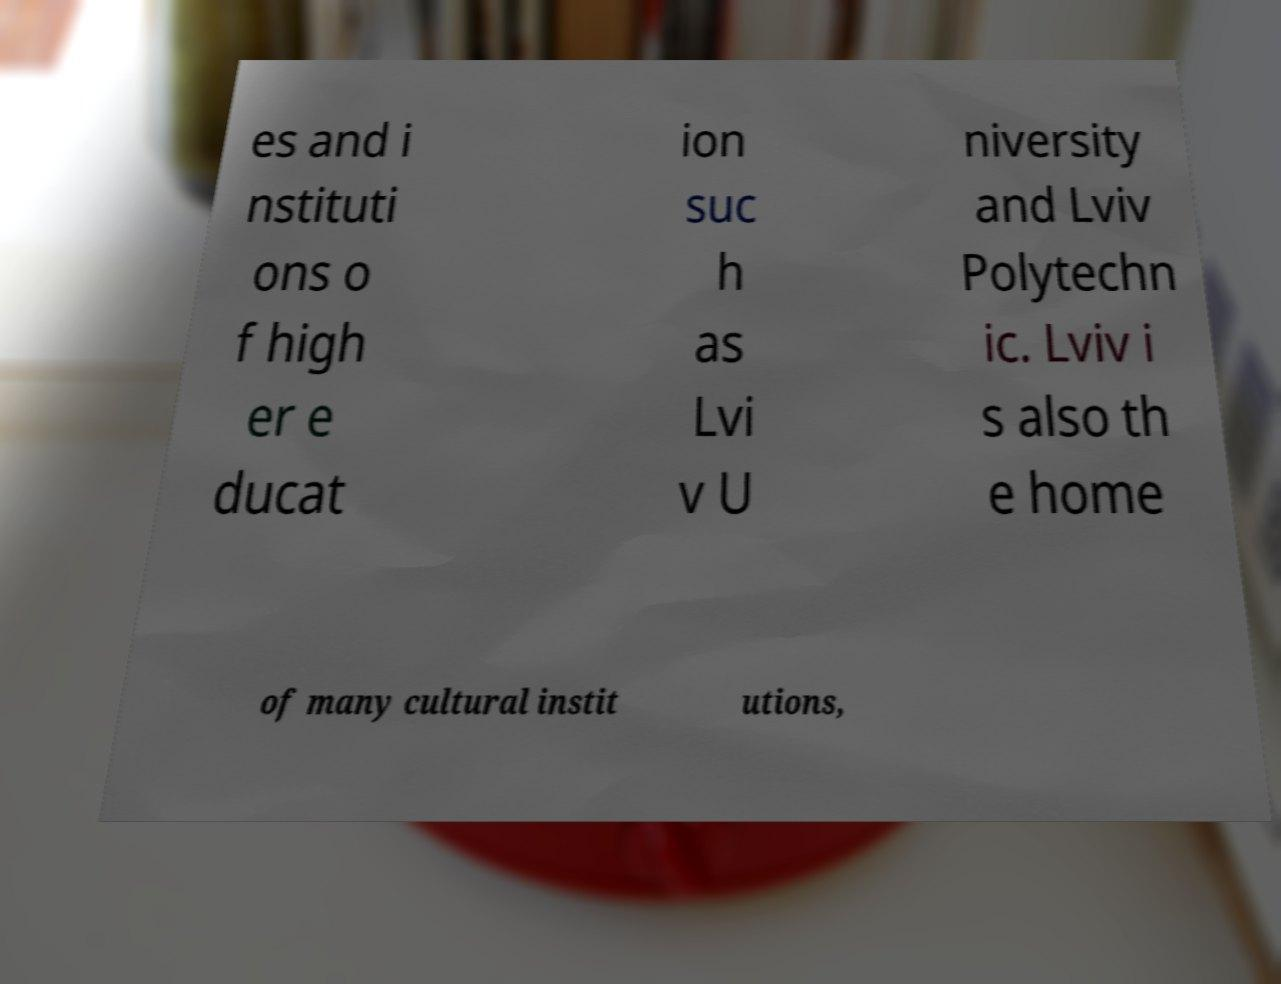Can you accurately transcribe the text from the provided image for me? es and i nstituti ons o f high er e ducat ion suc h as Lvi v U niversity and Lviv Polytechn ic. Lviv i s also th e home of many cultural instit utions, 